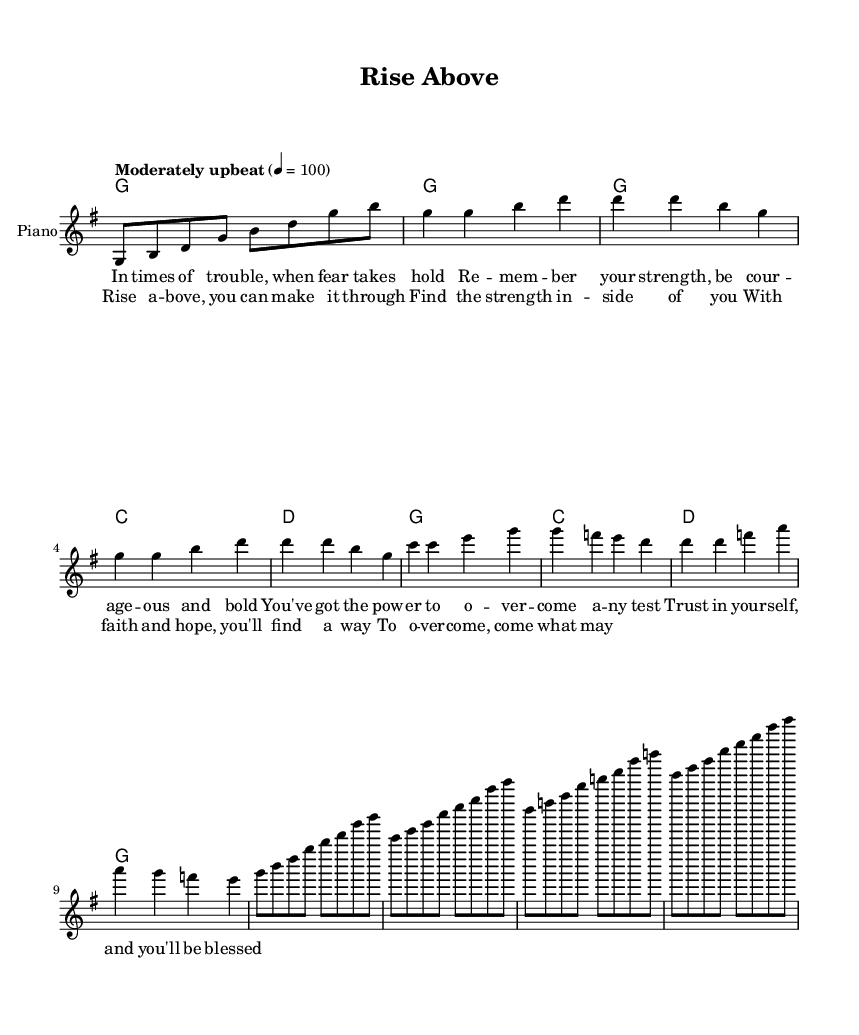What is the key signature of this music? The key signature is G major, which has one sharp (F sharp). This can be identified at the beginning of the staff where the sharps are indicated.
Answer: G major What is the time signature of the piece? The time signature is 4/4, as shown at the beginning of the music. This means there are four beats per measure, and the quarter note gets one beat.
Answer: 4/4 What is the tempo marking for this piece? The tempo marking reads "Moderately upbeat" followed by a tempo indication of 4 = 100. This means the piece should be played at a moderate pace while maintaining an upbeat feel.
Answer: Moderately upbeat How many measures are in the verse? The verse consists of eight measures, which can be counted by identifying each group separated by vertical lines in the music.
Answer: Eight What emotion is conveyed in the chorus section? The chorus conveys a message of hope and determination, emphasizing inner strength and faith to overcome challenges. This can be inferred from the uplifting lyrics and the melodic rise in notes.
Answer: Hope What is the repeated musical structure in the chorus? The chorus has a repeated structure with the same melody and lyrics that emphasize finding inner strength and making it through challenges, typically printed in bold or highlighted sections in sheet music.
Answer: Repeated Where can you find the lyrics in the music? The lyrics are placed directly below the melodic line where each note corresponds with the words, making it clear how the music aligns with the text.
Answer: Below the melody 